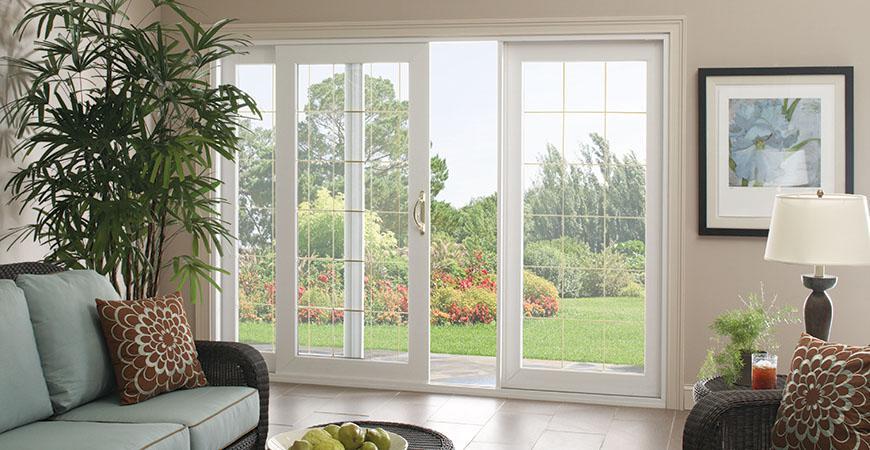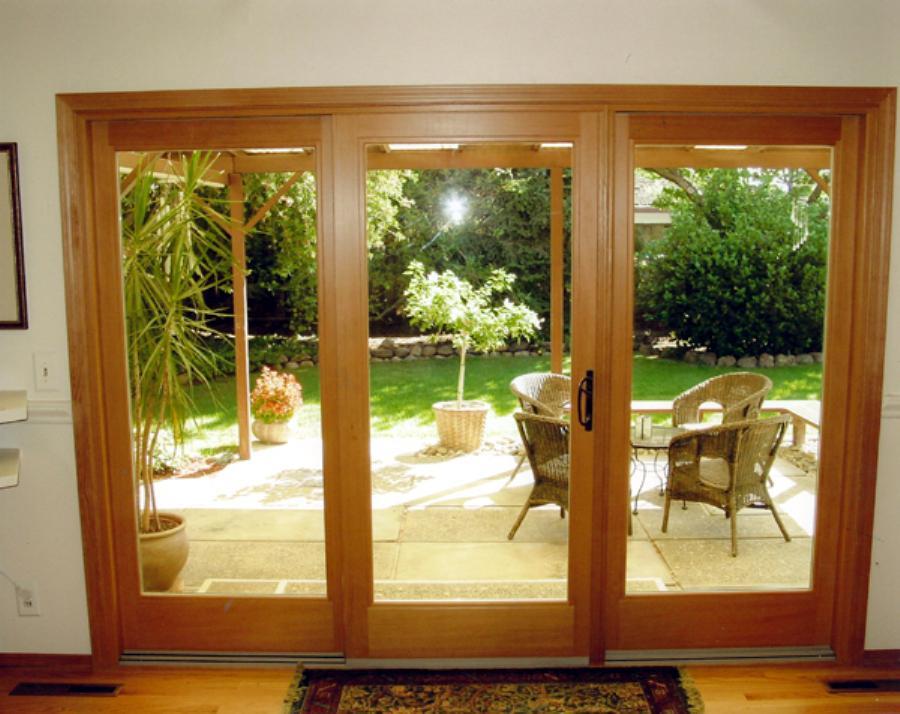The first image is the image on the left, the second image is the image on the right. Considering the images on both sides, is "Right and left images show the same sliding glass door in the same setting." valid? Answer yes or no. No. 